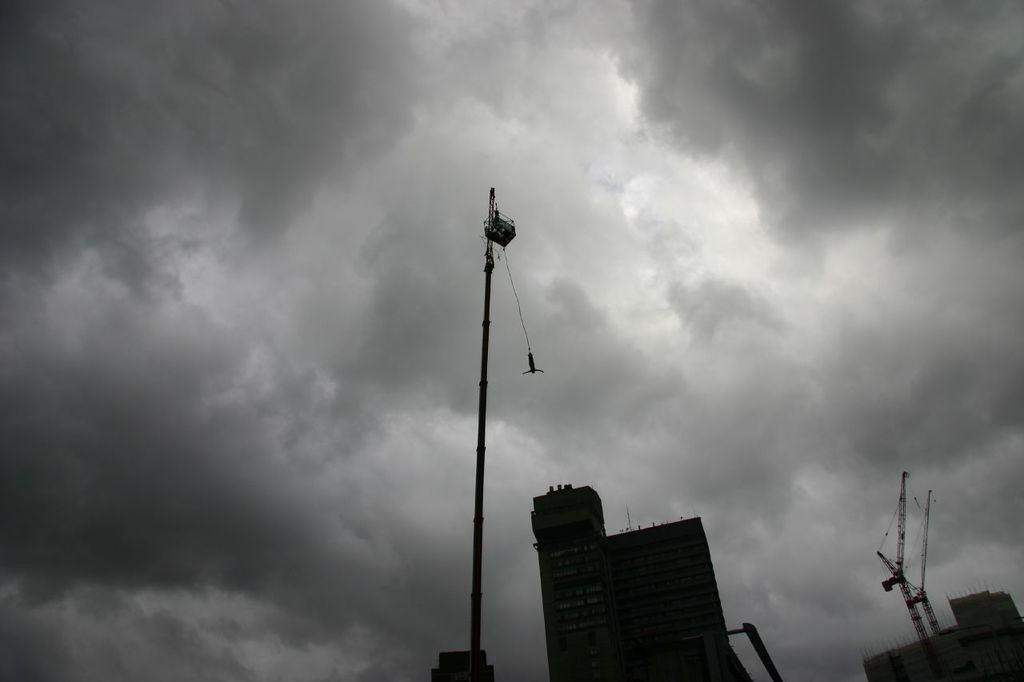Could you give a brief overview of what you see in this image? In this picture we can see buildings, cranes, pole, some objects and in the background we can see the sky with clouds. 